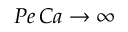<formula> <loc_0><loc_0><loc_500><loc_500>P e \, C a \rightarrow \infty</formula> 